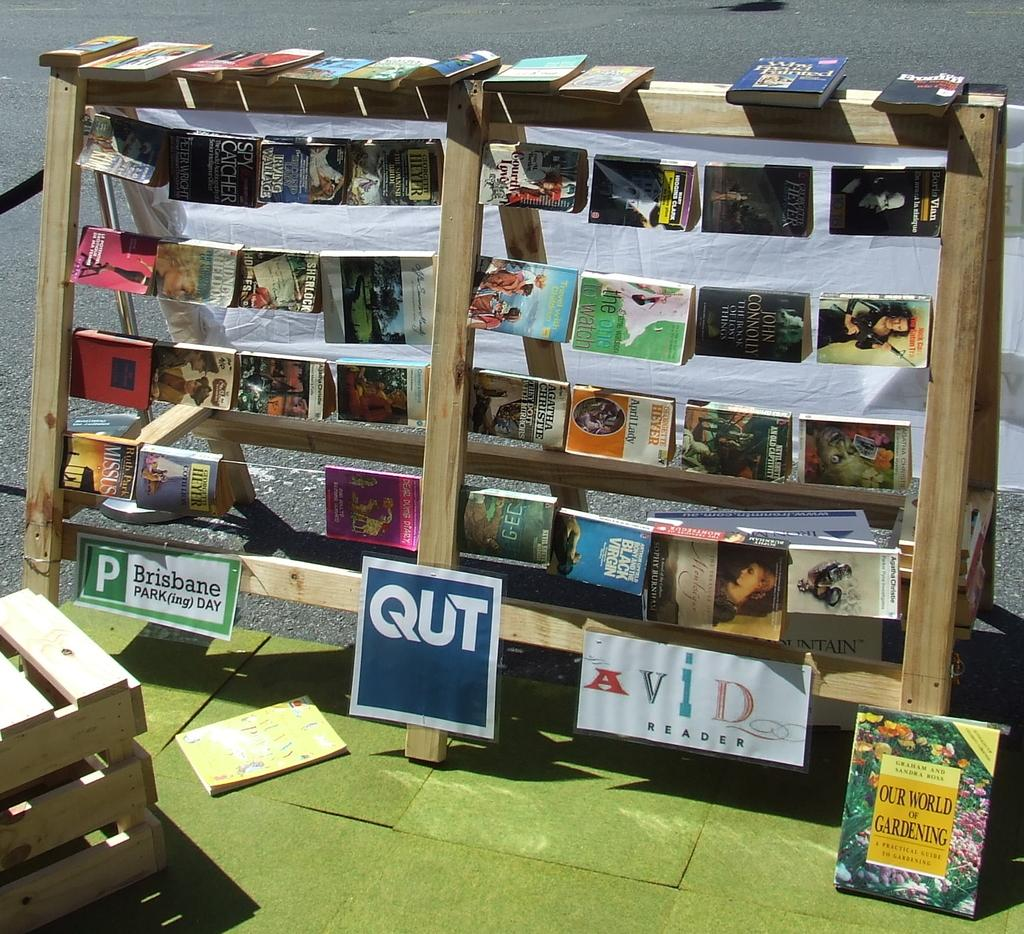<image>
Describe the image concisely. A collection of books are on display above a sign that says Avid Reader. 